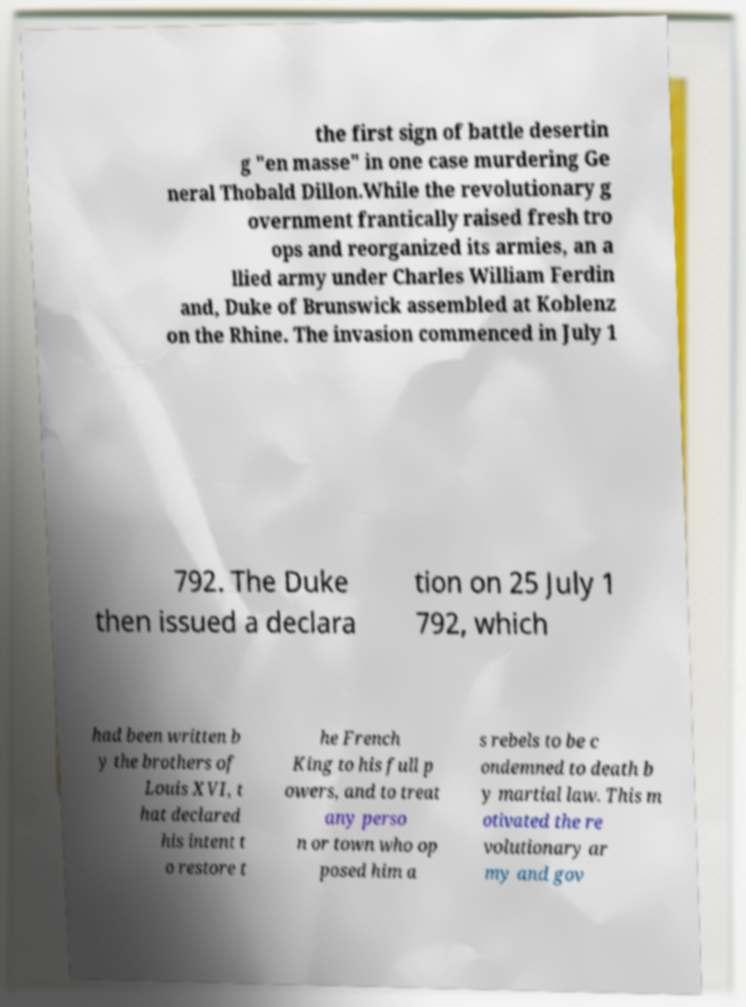Could you extract and type out the text from this image? the first sign of battle desertin g "en masse" in one case murdering Ge neral Thobald Dillon.While the revolutionary g overnment frantically raised fresh tro ops and reorganized its armies, an a llied army under Charles William Ferdin and, Duke of Brunswick assembled at Koblenz on the Rhine. The invasion commenced in July 1 792. The Duke then issued a declara tion on 25 July 1 792, which had been written b y the brothers of Louis XVI, t hat declared his intent t o restore t he French King to his full p owers, and to treat any perso n or town who op posed him a s rebels to be c ondemned to death b y martial law. This m otivated the re volutionary ar my and gov 